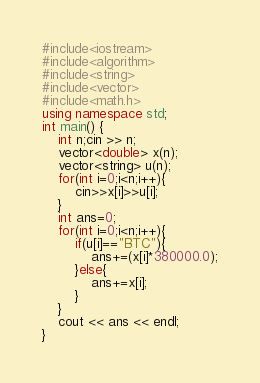<code> <loc_0><loc_0><loc_500><loc_500><_C++_>#include<iostream>
#include<algorithm>
#include<string>
#include<vector>
#include<math.h>
using namespace std;
int main() {
	int n;cin >> n;
    vector<double> x(n);
    vector<string> u(n);
    for(int i=0;i<n;i++){
        cin>>x[i]>>u[i];
    }
    int ans=0;
    for(int i=0;i<n;i++){
        if(u[i]=="BTC"){
            ans+=(x[i]*380000.0);
        }else{
            ans+=x[i];
        }
    }
    cout << ans << endl;
}</code> 